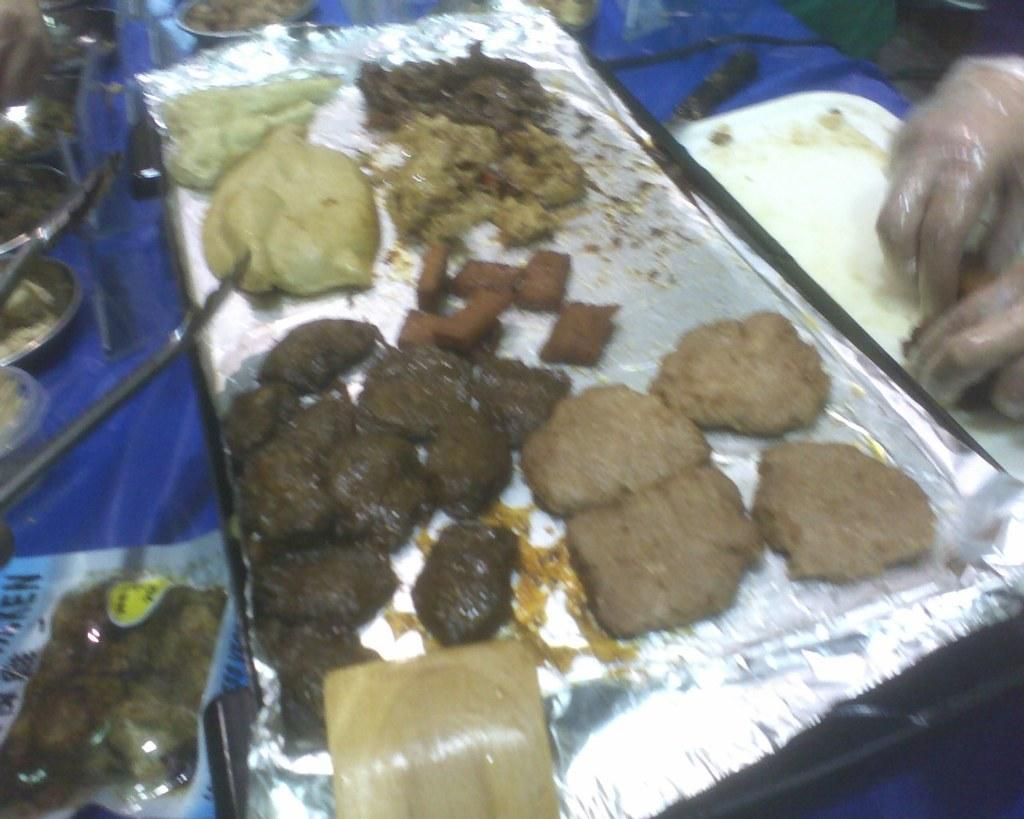What is on the plate in the image? There is food in a plate in the image. Can you describe anything else visible on the right side of the image? There are human hands with covers on the right side of the image. What type of letter is the pig holding in the image? There is no pig or letter present in the image. 